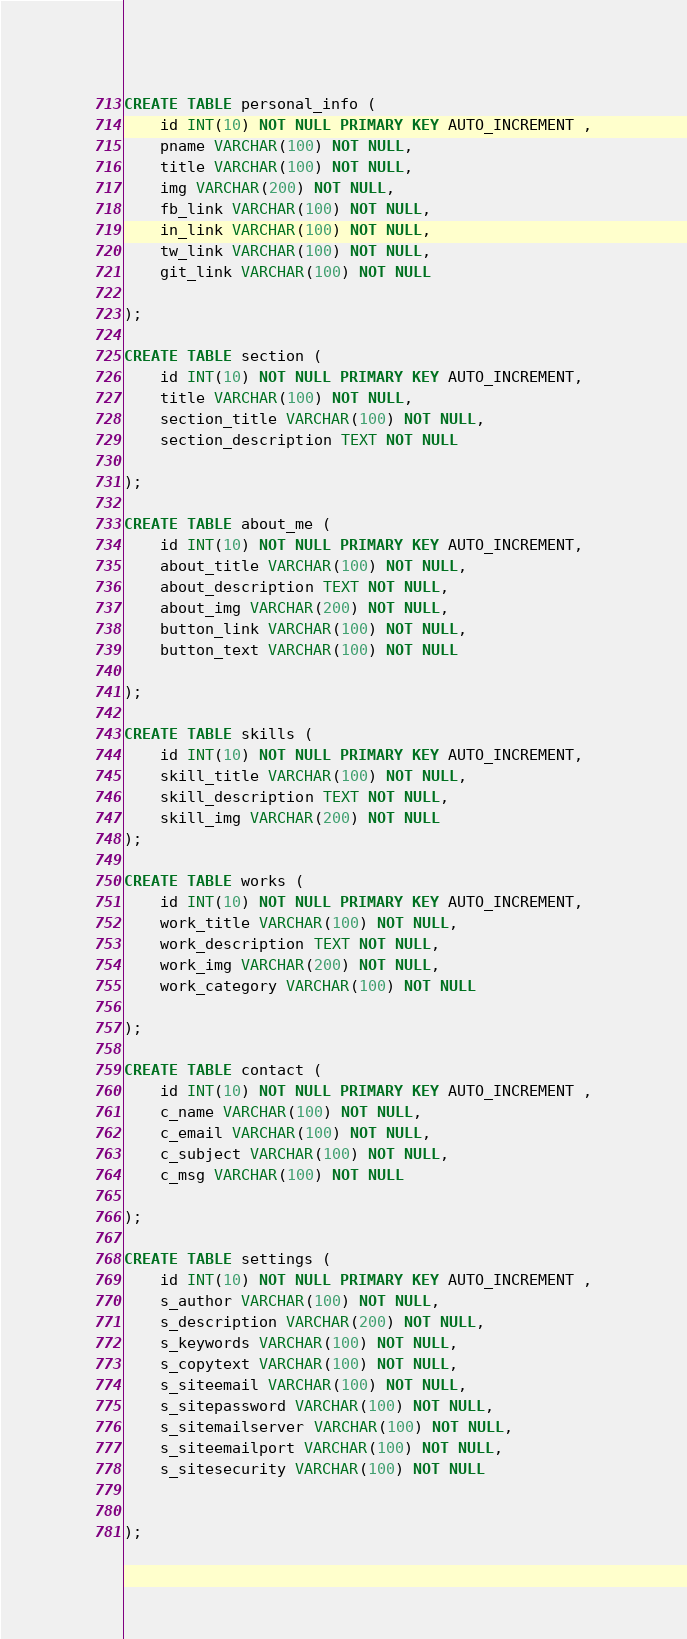Convert code to text. <code><loc_0><loc_0><loc_500><loc_500><_SQL_>
CREATE TABLE personal_info (
    id INT(10) NOT NULL PRIMARY KEY AUTO_INCREMENT ,
    pname VARCHAR(100) NOT NULL,
    title VARCHAR(100) NOT NULL,
    img VARCHAR(200) NOT NULL,
    fb_link VARCHAR(100) NOT NULL,
    in_link VARCHAR(100) NOT NULL,
    tw_link VARCHAR(100) NOT NULL,
    git_link VARCHAR(100) NOT NULL

);

CREATE TABLE section (
    id INT(10) NOT NULL PRIMARY KEY AUTO_INCREMENT,
    title VARCHAR(100) NOT NULL,
    section_title VARCHAR(100) NOT NULL,
    section_description TEXT NOT NULL

);
 
CREATE TABLE about_me (
    id INT(10) NOT NULL PRIMARY KEY AUTO_INCREMENT,
    about_title VARCHAR(100) NOT NULL,
    about_description TEXT NOT NULL,
    about_img VARCHAR(200) NOT NULL,
    button_link VARCHAR(100) NOT NULL,
    button_text VARCHAR(100) NOT NULL

);

CREATE TABLE skills (
    id INT(10) NOT NULL PRIMARY KEY AUTO_INCREMENT,
    skill_title VARCHAR(100) NOT NULL,
    skill_description TEXT NOT NULL,
    skill_img VARCHAR(200) NOT NULL
);

CREATE TABLE works (
    id INT(10) NOT NULL PRIMARY KEY AUTO_INCREMENT,
    work_title VARCHAR(100) NOT NULL,
    work_description TEXT NOT NULL,
    work_img VARCHAR(200) NOT NULL,
    work_category VARCHAR(100) NOT NULL

);

CREATE TABLE contact (
    id INT(10) NOT NULL PRIMARY KEY AUTO_INCREMENT ,
    c_name VARCHAR(100) NOT NULL,
    c_email VARCHAR(100) NOT NULL,
    c_subject VARCHAR(100) NOT NULL,
    c_msg VARCHAR(100) NOT NULL

);

CREATE TABLE settings (
    id INT(10) NOT NULL PRIMARY KEY AUTO_INCREMENT ,
    s_author VARCHAR(100) NOT NULL,
    s_description VARCHAR(200) NOT NULL,
    s_keywords VARCHAR(100) NOT NULL,
    s_copytext VARCHAR(100) NOT NULL,
    s_siteemail VARCHAR(100) NOT NULL,
    s_sitepassword VARCHAR(100) NOT NULL,
    s_sitemailserver VARCHAR(100) NOT NULL,
    s_siteemailport VARCHAR(100) NOT NULL,
    s_sitesecurity VARCHAR(100) NOT NULL


);</code> 